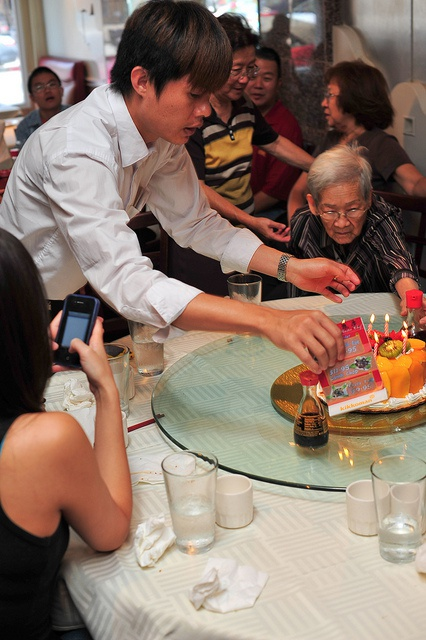Describe the objects in this image and their specific colors. I can see dining table in darkgray, lightgray, and tan tones, people in darkgray, lightgray, black, and brown tones, people in darkgray, black, brown, and salmon tones, people in darkgray, black, brown, and maroon tones, and people in darkgray, black, maroon, and brown tones in this image. 